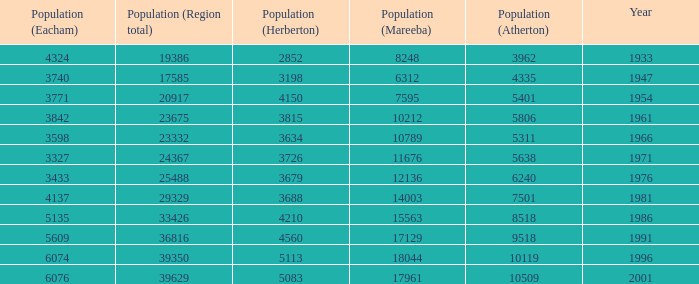How many figures are given for the region's total in 1947? 1.0. 